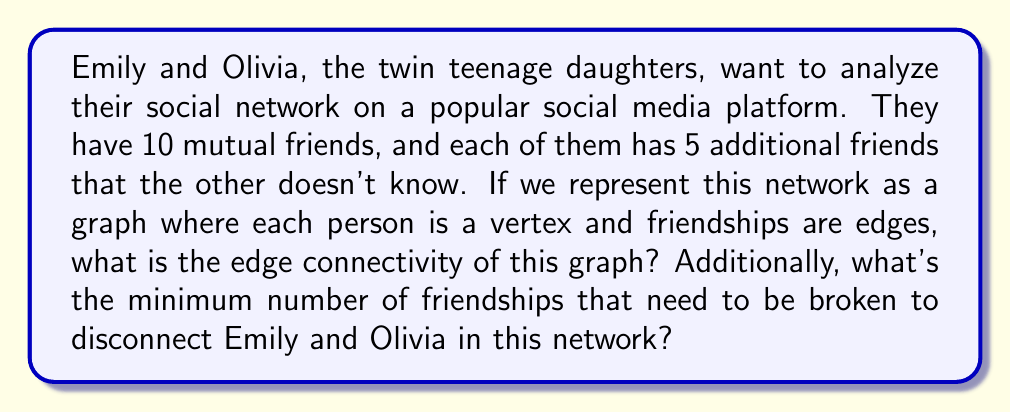What is the answer to this math problem? Let's approach this step-by-step:

1) First, let's visualize the graph:
   - Emily and Olivia are two vertices
   - There are 10 vertices representing their mutual friends
   - There are 5 vertices connected only to Emily
   - There are 5 vertices connected only to Olivia

2) The total number of vertices in this graph is:
   $$ 2 + 10 + 5 + 5 = 22 $$

3) Now, let's consider the connections:
   - Emily is connected to Olivia (1 edge)
   - Emily and Olivia are each connected to all 10 mutual friends (20 edges)
   - Emily is connected to her 5 unique friends (5 edges)
   - Olivia is connected to her 5 unique friends (5 edges)

4) The edge connectivity of a graph is the minimum number of edges that need to be removed to disconnect the graph.

5) In this case, to disconnect Emily and Olivia, we need to remove:
   - The direct edge between them
   - All edges connecting Emily to the mutual friends
   - All edges connecting Olivia to the mutual friends

6) The total number of edges to remove is:
   $$ 1 + 10 + 10 = 21 $$

7) This is also the edge connectivity of the graph, as removing these 21 edges will disconnect Emily and Olivia, and there's no way to disconnect them by removing fewer edges.

Therefore, the edge connectivity of this graph is 21, which is also the minimum number of friendships that need to be broken to disconnect Emily and Olivia in this network.
Answer: The edge connectivity of the graph is 21. The minimum number of friendships that need to be broken to disconnect Emily and Olivia in this network is also 21. 